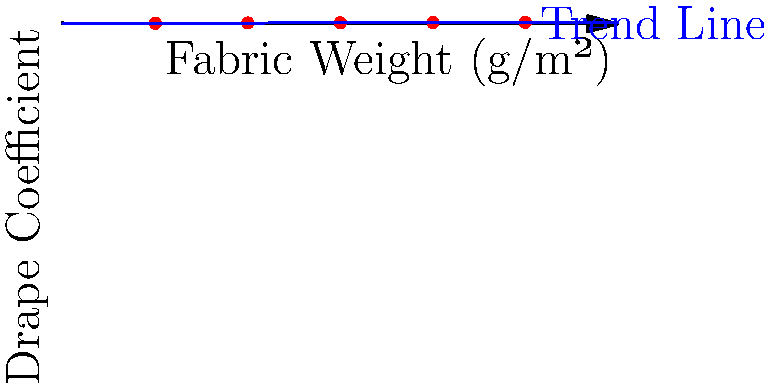As a fashion illustrator collaborating with a student on fabric draping patterns, you're working on a machine learning model to predict drape coefficients. Given the scatter plot showing the relationship between fabric weight and drape coefficient, what type of regression model would be most appropriate for this data, and what does the trend suggest about the relationship between fabric weight and drape coefficient? To answer this question, let's analyze the scatter plot step-by-step:

1. Data distribution: The plot shows fabric weight (g/m²) on the x-axis and drape coefficient on the y-axis.

2. Data points: There are five red dots representing individual data points.

3. Trend line: A blue line is drawn through the data points, representing the overall trend.

4. Linearity: The trend line appears to be straight, suggesting a linear relationship between fabric weight and drape coefficient.

5. Correlation: As the fabric weight increases, the drape coefficient also increases, indicating a positive correlation.

6. Slope: The trend line has a positive slope, confirming the positive relationship between the variables.

7. Model selection: Given the apparent linear relationship, a simple linear regression model would be most appropriate for this data.

8. Interpretation: The trend suggests that as fabric weight increases, the drape coefficient also increases. This means heavier fabrics tend to have higher drape coefficients, implying they are less likely to drape freely and may hold their shape more rigidly.

9. Mathematical representation: The linear relationship can be expressed as:

   $$ y = mx + b $$

   Where $y$ is the drape coefficient, $x$ is the fabric weight, $m$ is the slope, and $b$ is the y-intercept.

10. Limitations: While the linear model seems appropriate for this range of data, it's important to note that the relationship might not remain linear for extreme fabric weights outside the given range.
Answer: Linear regression; heavier fabrics have higher drape coefficients. 